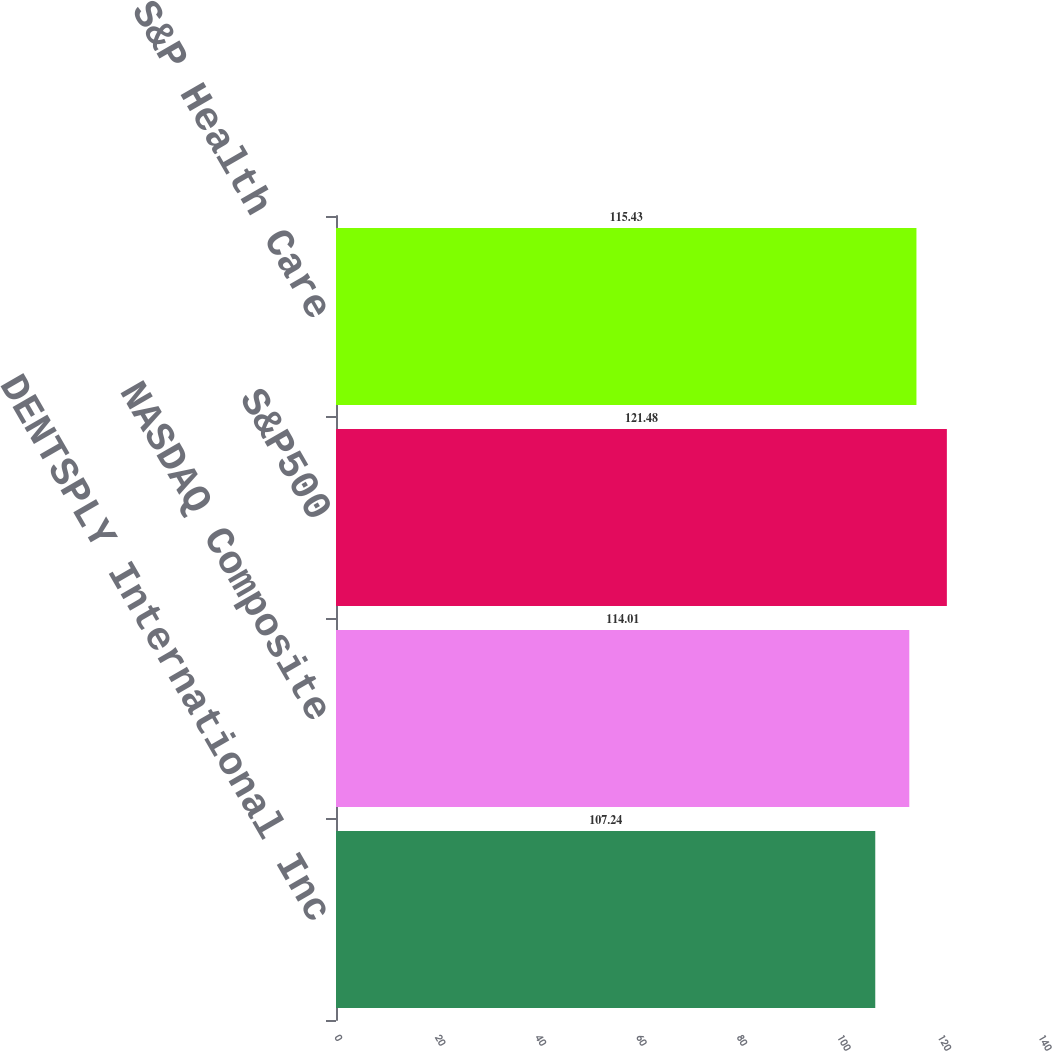<chart> <loc_0><loc_0><loc_500><loc_500><bar_chart><fcel>DENTSPLY International Inc<fcel>NASDAQ Composite<fcel>S&P500<fcel>S&P Health Care<nl><fcel>107.24<fcel>114.01<fcel>121.48<fcel>115.43<nl></chart> 